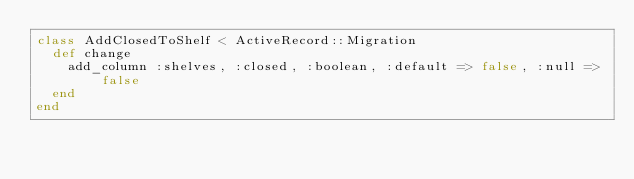<code> <loc_0><loc_0><loc_500><loc_500><_Ruby_>class AddClosedToShelf < ActiveRecord::Migration
  def change
    add_column :shelves, :closed, :boolean, :default => false, :null => false
  end
end
</code> 